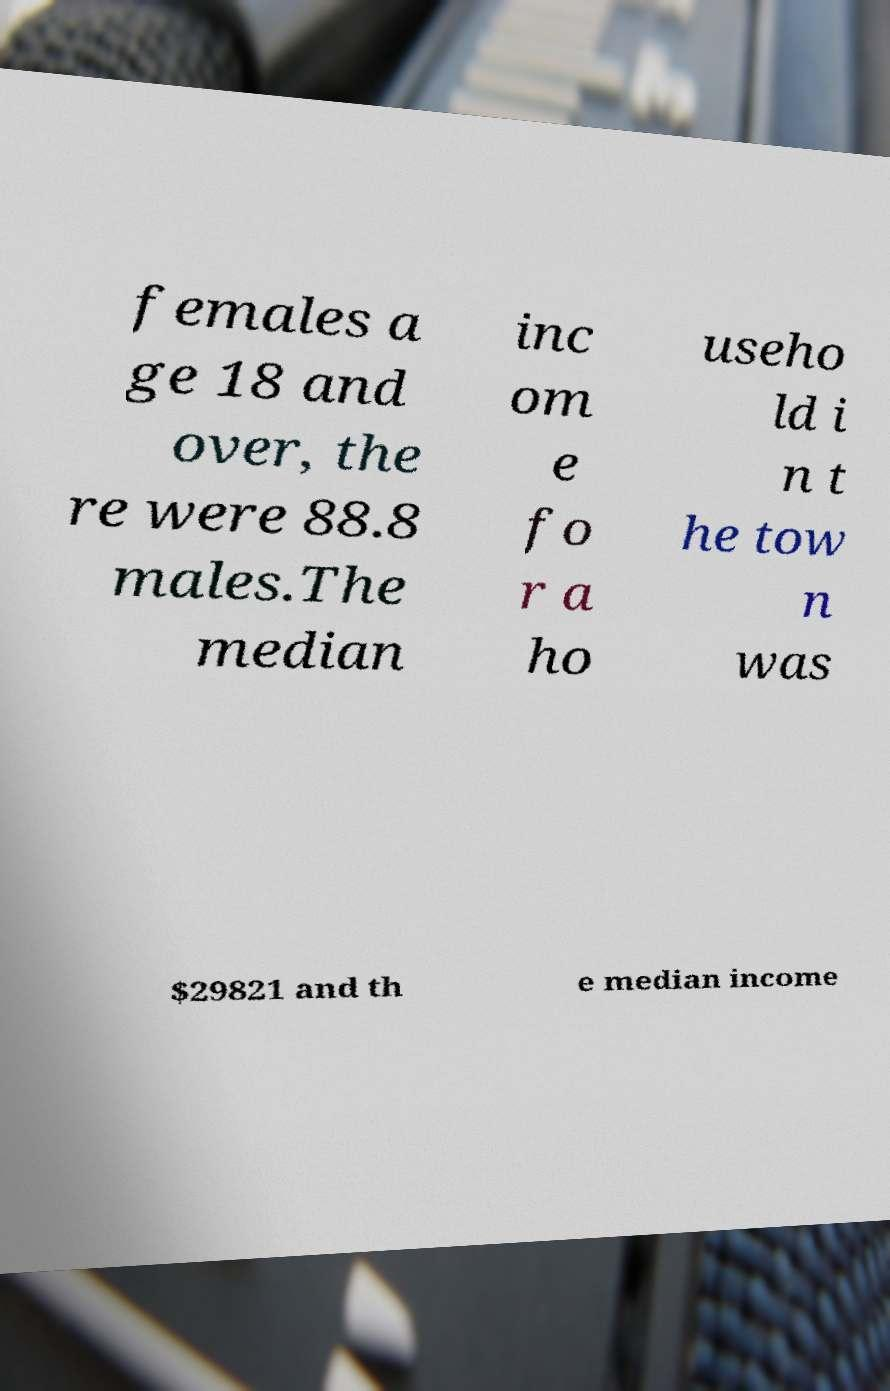Please read and relay the text visible in this image. What does it say? females a ge 18 and over, the re were 88.8 males.The median inc om e fo r a ho useho ld i n t he tow n was $29821 and th e median income 